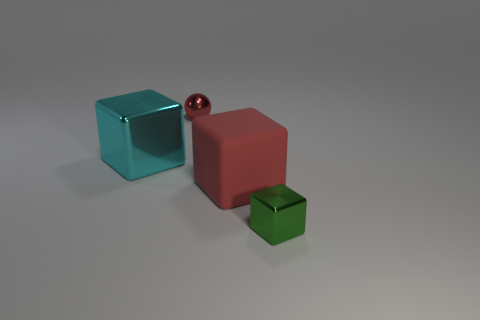Is there anything else that has the same material as the red block?
Your response must be concise. No. Is there anything else that is the same color as the sphere?
Provide a short and direct response. Yes. There is a big thing that is the same color as the sphere; what is its shape?
Make the answer very short. Cube. There is a thing that is behind the cyan metal cube; how big is it?
Provide a short and direct response. Small. What shape is the other matte thing that is the same size as the cyan object?
Offer a terse response. Cube. Do the tiny object left of the tiny green cube and the large object that is left of the red sphere have the same material?
Keep it short and to the point. Yes. There is a red object that is right of the small metal object that is behind the small cube; what is it made of?
Ensure brevity in your answer.  Rubber. There is a sphere that is to the right of the shiny block that is behind the small metal object right of the tiny ball; how big is it?
Keep it short and to the point. Small. Do the cyan thing and the red block have the same size?
Ensure brevity in your answer.  Yes. There is a red thing on the right side of the tiny shiny sphere; is it the same shape as the object that is on the right side of the large matte block?
Your response must be concise. Yes. 